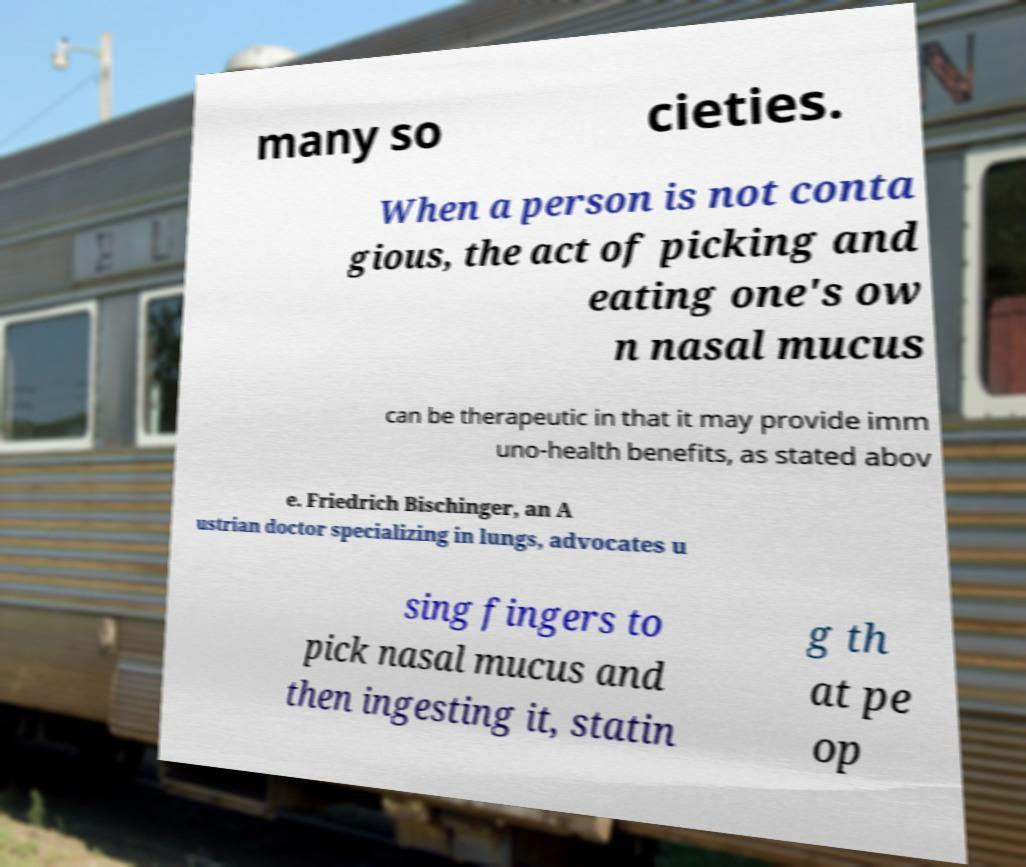Please identify and transcribe the text found in this image. many so cieties. When a person is not conta gious, the act of picking and eating one's ow n nasal mucus can be therapeutic in that it may provide imm uno-health benefits, as stated abov e. Friedrich Bischinger, an A ustrian doctor specializing in lungs, advocates u sing fingers to pick nasal mucus and then ingesting it, statin g th at pe op 